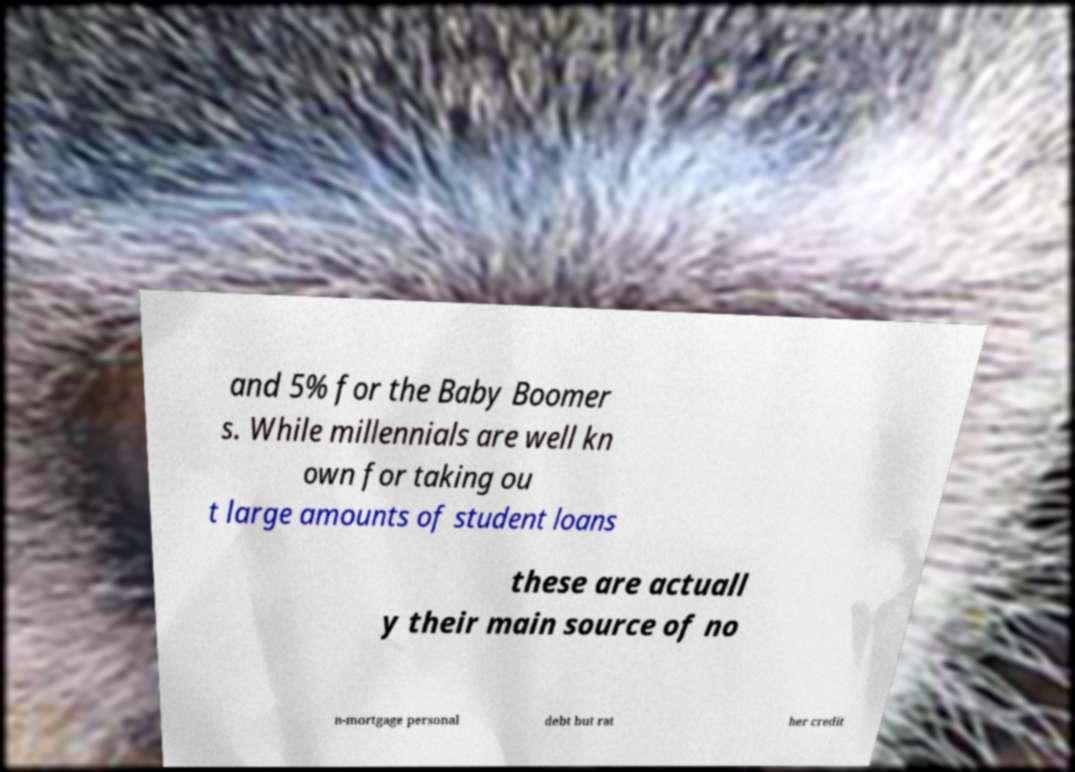For documentation purposes, I need the text within this image transcribed. Could you provide that? and 5% for the Baby Boomer s. While millennials are well kn own for taking ou t large amounts of student loans these are actuall y their main source of no n-mortgage personal debt but rat her credit 